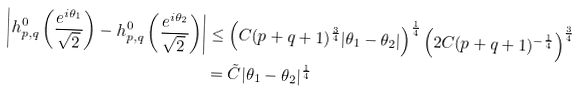Convert formula to latex. <formula><loc_0><loc_0><loc_500><loc_500>\left | h _ { p , q } ^ { 0 } \left ( \frac { e ^ { i \theta _ { 1 } } } { \sqrt { 2 } } \right ) - h _ { p , q } ^ { 0 } \left ( \frac { e ^ { i \theta _ { 2 } } } { \sqrt { 2 } } \right ) \right | & \leq \left ( C ( p + q + 1 ) ^ { \frac { 3 } { 4 } } | \theta _ { 1 } - \theta _ { 2 } | \right ) ^ { \frac { 1 } { 4 } } \left ( 2 C ( p + q + 1 ) ^ { - \frac { 1 } { 4 } } \right ) ^ { \frac { 3 } { 4 } } \\ & = \tilde { C } | \theta _ { 1 } - \theta _ { 2 } | ^ { \frac { 1 } { 4 } }</formula> 